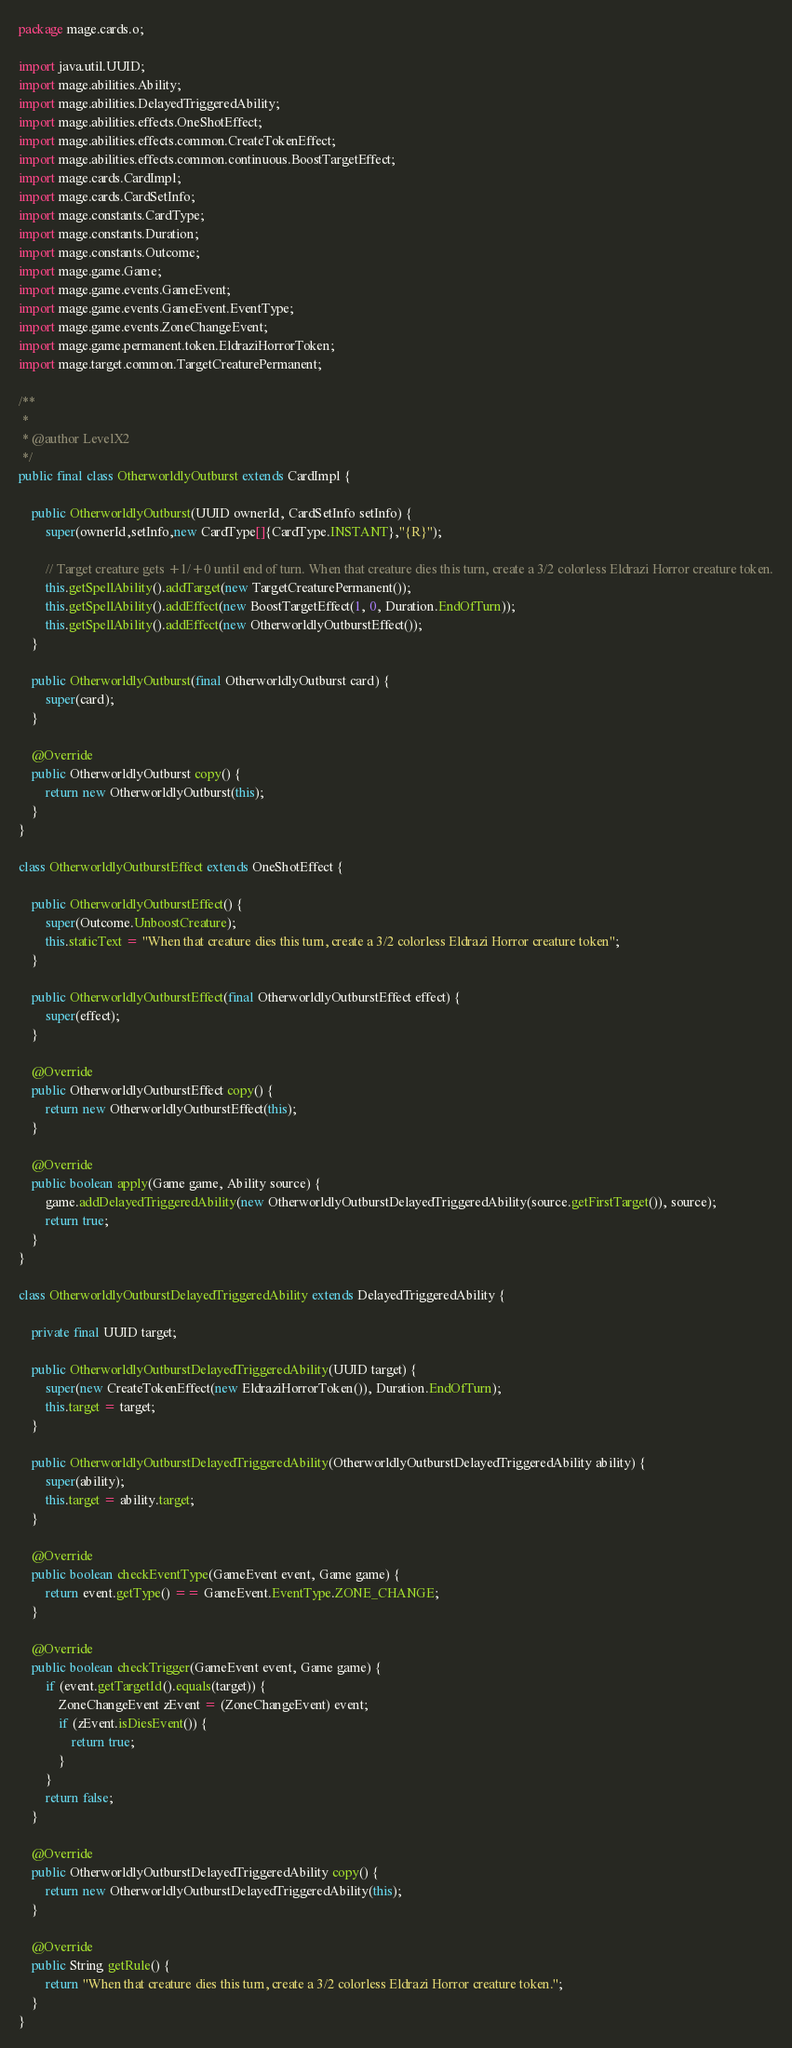Convert code to text. <code><loc_0><loc_0><loc_500><loc_500><_Java_>
package mage.cards.o;

import java.util.UUID;
import mage.abilities.Ability;
import mage.abilities.DelayedTriggeredAbility;
import mage.abilities.effects.OneShotEffect;
import mage.abilities.effects.common.CreateTokenEffect;
import mage.abilities.effects.common.continuous.BoostTargetEffect;
import mage.cards.CardImpl;
import mage.cards.CardSetInfo;
import mage.constants.CardType;
import mage.constants.Duration;
import mage.constants.Outcome;
import mage.game.Game;
import mage.game.events.GameEvent;
import mage.game.events.GameEvent.EventType;
import mage.game.events.ZoneChangeEvent;
import mage.game.permanent.token.EldraziHorrorToken;
import mage.target.common.TargetCreaturePermanent;

/**
 *
 * @author LevelX2
 */
public final class OtherworldlyOutburst extends CardImpl {

    public OtherworldlyOutburst(UUID ownerId, CardSetInfo setInfo) {
        super(ownerId,setInfo,new CardType[]{CardType.INSTANT},"{R}");

        // Target creature gets +1/+0 until end of turn. When that creature dies this turn, create a 3/2 colorless Eldrazi Horror creature token.
        this.getSpellAbility().addTarget(new TargetCreaturePermanent());
        this.getSpellAbility().addEffect(new BoostTargetEffect(1, 0, Duration.EndOfTurn));
        this.getSpellAbility().addEffect(new OtherworldlyOutburstEffect());
    }

    public OtherworldlyOutburst(final OtherworldlyOutburst card) {
        super(card);
    }

    @Override
    public OtherworldlyOutburst copy() {
        return new OtherworldlyOutburst(this);
    }
}

class OtherworldlyOutburstEffect extends OneShotEffect {

    public OtherworldlyOutburstEffect() {
        super(Outcome.UnboostCreature);
        this.staticText = "When that creature dies this turn, create a 3/2 colorless Eldrazi Horror creature token";
    }

    public OtherworldlyOutburstEffect(final OtherworldlyOutburstEffect effect) {
        super(effect);
    }

    @Override
    public OtherworldlyOutburstEffect copy() {
        return new OtherworldlyOutburstEffect(this);
    }

    @Override
    public boolean apply(Game game, Ability source) {
        game.addDelayedTriggeredAbility(new OtherworldlyOutburstDelayedTriggeredAbility(source.getFirstTarget()), source);
        return true;
    }
}

class OtherworldlyOutburstDelayedTriggeredAbility extends DelayedTriggeredAbility {

    private final UUID target;

    public OtherworldlyOutburstDelayedTriggeredAbility(UUID target) {
        super(new CreateTokenEffect(new EldraziHorrorToken()), Duration.EndOfTurn);
        this.target = target;
    }

    public OtherworldlyOutburstDelayedTriggeredAbility(OtherworldlyOutburstDelayedTriggeredAbility ability) {
        super(ability);
        this.target = ability.target;
    }

    @Override
    public boolean checkEventType(GameEvent event, Game game) {
        return event.getType() == GameEvent.EventType.ZONE_CHANGE;
    }

    @Override
    public boolean checkTrigger(GameEvent event, Game game) {
        if (event.getTargetId().equals(target)) {
            ZoneChangeEvent zEvent = (ZoneChangeEvent) event;
            if (zEvent.isDiesEvent()) {
                return true;
            }
        }
        return false;
    }

    @Override
    public OtherworldlyOutburstDelayedTriggeredAbility copy() {
        return new OtherworldlyOutburstDelayedTriggeredAbility(this);
    }

    @Override
    public String getRule() {
        return "When that creature dies this turn, create a 3/2 colorless Eldrazi Horror creature token.";
    }
}
</code> 